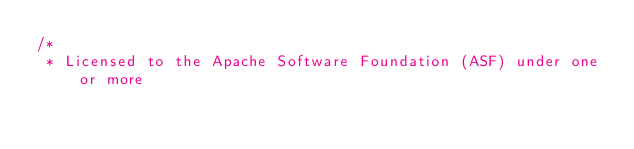Convert code to text. <code><loc_0><loc_0><loc_500><loc_500><_C++_>/*
 * Licensed to the Apache Software Foundation (ASF) under one or more</code> 